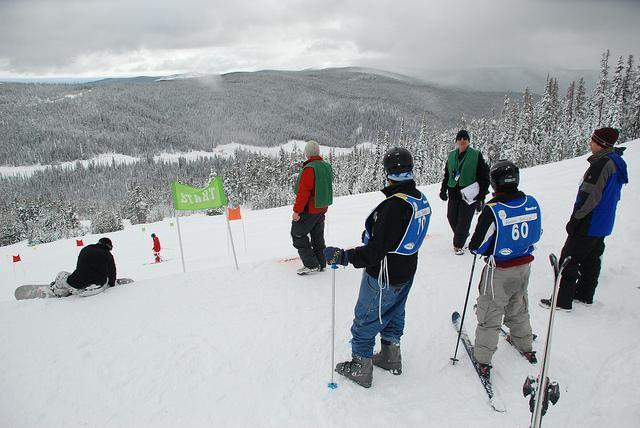How many people are there?
Give a very brief answer. 6. 